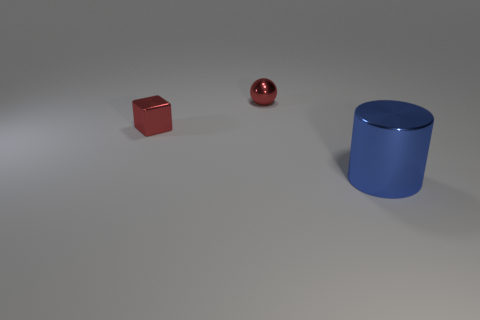Add 3 small red metal blocks. How many objects exist? 6 Subtract all balls. How many objects are left? 2 Add 2 red metal objects. How many red metal objects exist? 4 Subtract 0 red cylinders. How many objects are left? 3 Subtract all large metal objects. Subtract all small red blocks. How many objects are left? 1 Add 3 tiny red metal blocks. How many tiny red metal blocks are left? 4 